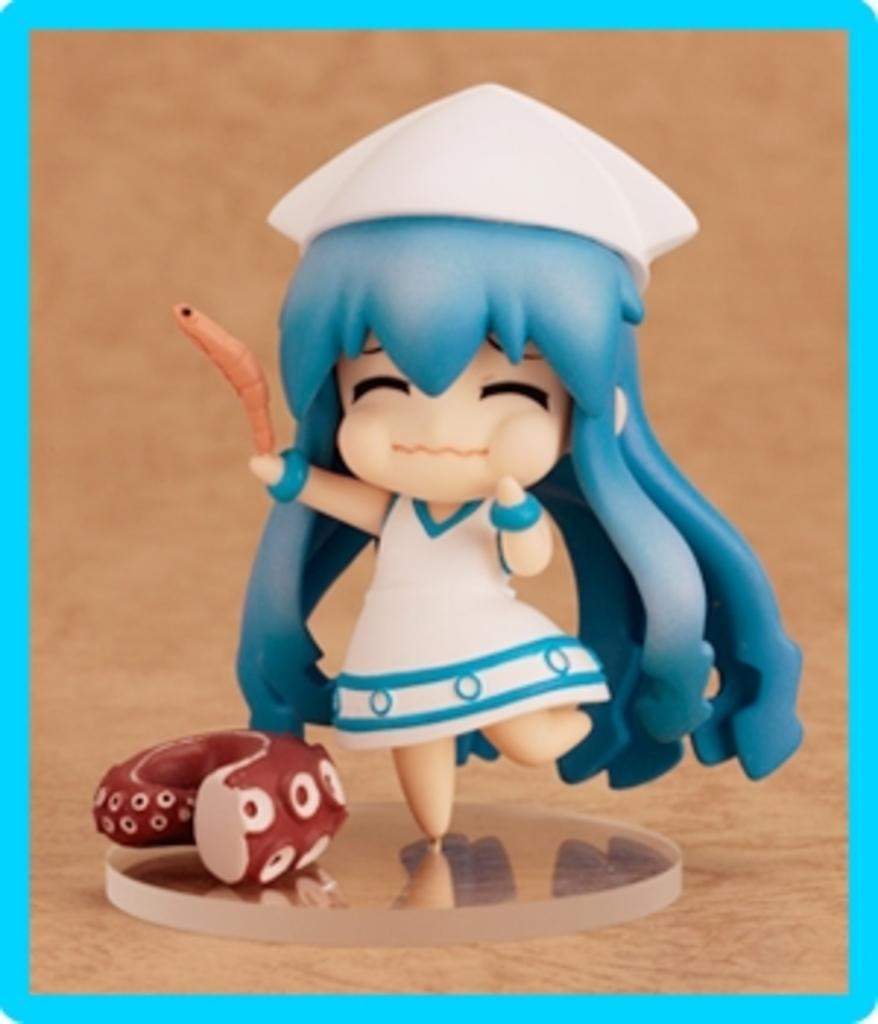Please provide a concise description of this image. In this picture we can see a toy on the platform. 